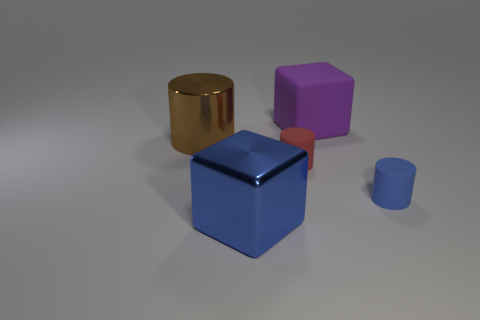What is the color of the block that is in front of the big object left of the blue cube?
Offer a very short reply. Blue. What size is the cube to the left of the large block behind the metal object that is behind the big blue metallic object?
Your response must be concise. Large. Is the big blue block made of the same material as the block behind the metal cylinder?
Your response must be concise. No. What size is the other cylinder that is made of the same material as the small red cylinder?
Keep it short and to the point. Small. Are there any small yellow rubber things of the same shape as the brown object?
Make the answer very short. No. How many objects are either cubes in front of the red cylinder or big blue metal balls?
Give a very brief answer. 1. What size is the cylinder that is the same color as the big metal cube?
Make the answer very short. Small. Does the matte cylinder left of the small blue cylinder have the same color as the big object behind the big brown object?
Your answer should be compact. No. How big is the blue shiny object?
Your answer should be compact. Large. What number of small objects are either gray matte spheres or blue blocks?
Keep it short and to the point. 0. 